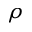<formula> <loc_0><loc_0><loc_500><loc_500>\rho</formula> 